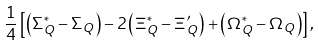<formula> <loc_0><loc_0><loc_500><loc_500>\frac { 1 } { 4 } \left [ \left ( \Sigma _ { Q } ^ { * } - \Sigma _ { Q } \right ) - 2 \left ( \Xi _ { Q } ^ { * } - \Xi _ { Q } ^ { \prime } \right ) + \left ( \Omega _ { Q } ^ { * } - \Omega _ { Q } \right ) \right ] ,</formula> 